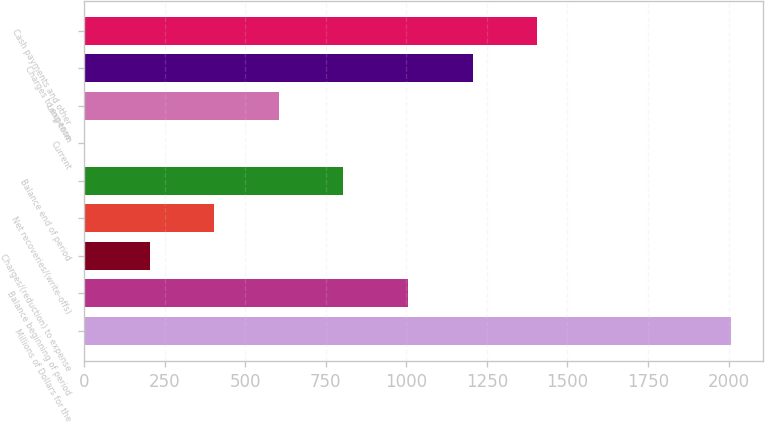Convert chart to OTSL. <chart><loc_0><loc_0><loc_500><loc_500><bar_chart><fcel>Millions of Dollars for the<fcel>Balance beginning of period<fcel>Charges/(reduction) to expense<fcel>Net recoveries/(write-offs)<fcel>Balance end of period<fcel>Current<fcel>Long-term<fcel>Charges to expense<fcel>Cash payments and other<nl><fcel>2007<fcel>1005<fcel>203.4<fcel>403.8<fcel>804.6<fcel>3<fcel>604.2<fcel>1205.4<fcel>1405.8<nl></chart> 